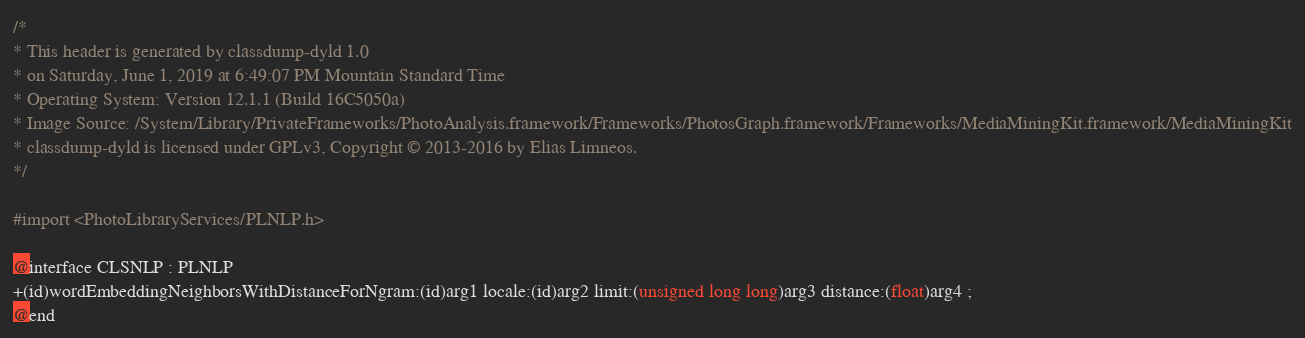<code> <loc_0><loc_0><loc_500><loc_500><_C_>/*
* This header is generated by classdump-dyld 1.0
* on Saturday, June 1, 2019 at 6:49:07 PM Mountain Standard Time
* Operating System: Version 12.1.1 (Build 16C5050a)
* Image Source: /System/Library/PrivateFrameworks/PhotoAnalysis.framework/Frameworks/PhotosGraph.framework/Frameworks/MediaMiningKit.framework/MediaMiningKit
* classdump-dyld is licensed under GPLv3, Copyright © 2013-2016 by Elias Limneos.
*/

#import <PhotoLibraryServices/PLNLP.h>

@interface CLSNLP : PLNLP
+(id)wordEmbeddingNeighborsWithDistanceForNgram:(id)arg1 locale:(id)arg2 limit:(unsigned long long)arg3 distance:(float)arg4 ;
@end

</code> 